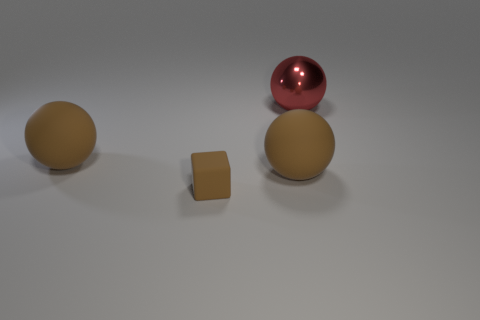What is the texture of the objects in the image? The objects appear to have a smooth texture, with the red sphere showing a reflective shiny surface, while the brown objects have a matte finish. 